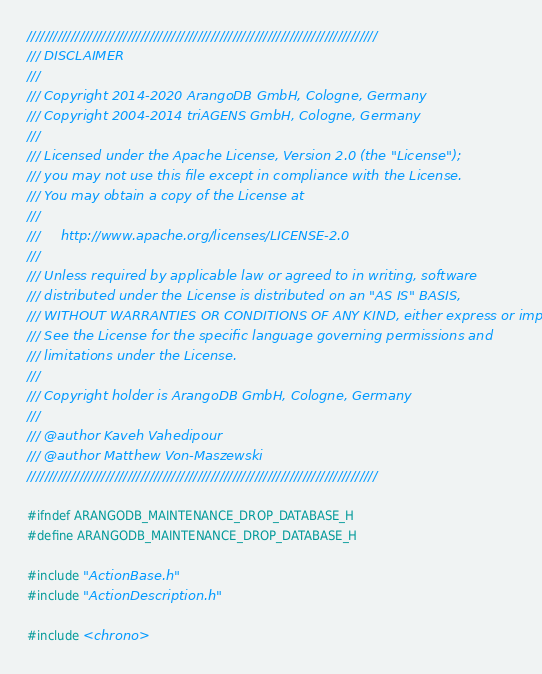<code> <loc_0><loc_0><loc_500><loc_500><_C_>////////////////////////////////////////////////////////////////////////////////
/// DISCLAIMER
///
/// Copyright 2014-2020 ArangoDB GmbH, Cologne, Germany
/// Copyright 2004-2014 triAGENS GmbH, Cologne, Germany
///
/// Licensed under the Apache License, Version 2.0 (the "License");
/// you may not use this file except in compliance with the License.
/// You may obtain a copy of the License at
///
///     http://www.apache.org/licenses/LICENSE-2.0
///
/// Unless required by applicable law or agreed to in writing, software
/// distributed under the License is distributed on an "AS IS" BASIS,
/// WITHOUT WARRANTIES OR CONDITIONS OF ANY KIND, either express or implied.
/// See the License for the specific language governing permissions and
/// limitations under the License.
///
/// Copyright holder is ArangoDB GmbH, Cologne, Germany
///
/// @author Kaveh Vahedipour
/// @author Matthew Von-Maszewski
////////////////////////////////////////////////////////////////////////////////

#ifndef ARANGODB_MAINTENANCE_DROP_DATABASE_H
#define ARANGODB_MAINTENANCE_DROP_DATABASE_H

#include "ActionBase.h"
#include "ActionDescription.h"

#include <chrono>
</code> 